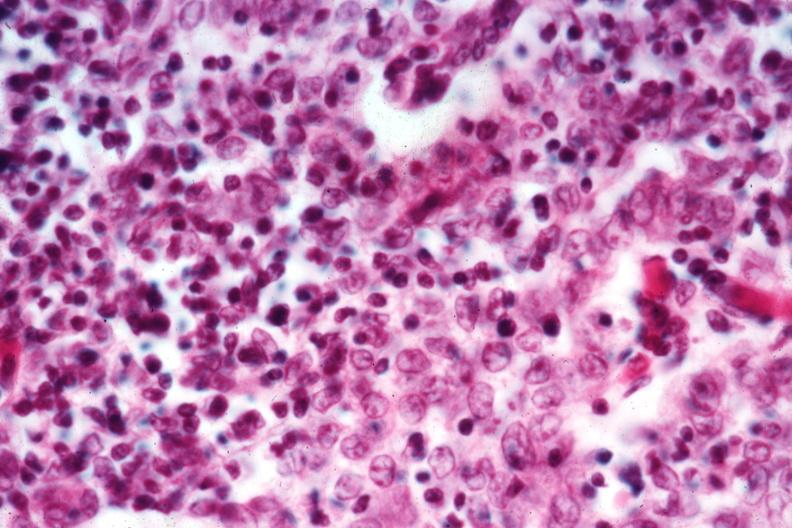what is present?
Answer the question using a single word or phrase. Thymus 